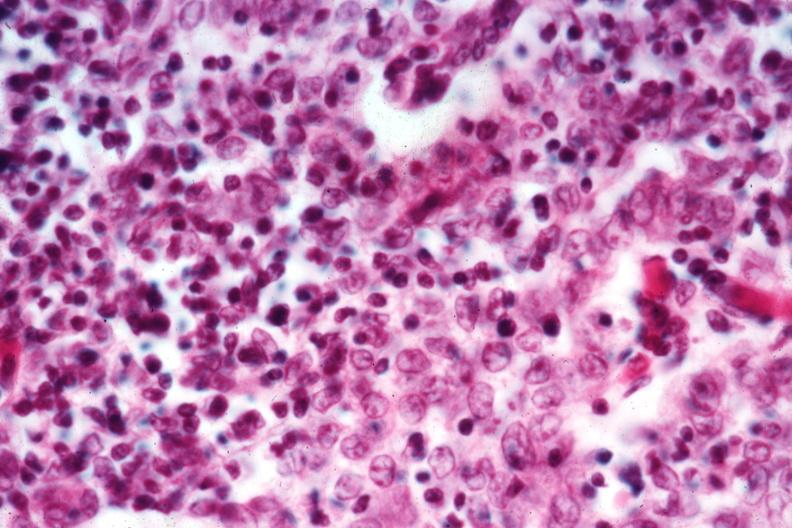what is present?
Answer the question using a single word or phrase. Thymus 